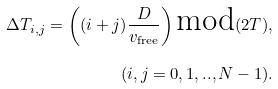Convert formula to latex. <formula><loc_0><loc_0><loc_500><loc_500>\Delta T _ { i , j } = \left ( ( i + j ) \frac { D } { v _ { \text {free} } } \right ) \text {mod} ( 2 T ) , \\ ( i , j = 0 , 1 , . . , N - 1 ) .</formula> 